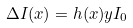Convert formula to latex. <formula><loc_0><loc_0><loc_500><loc_500>\Delta I ( x ) = h ( x ) y I _ { 0 }</formula> 